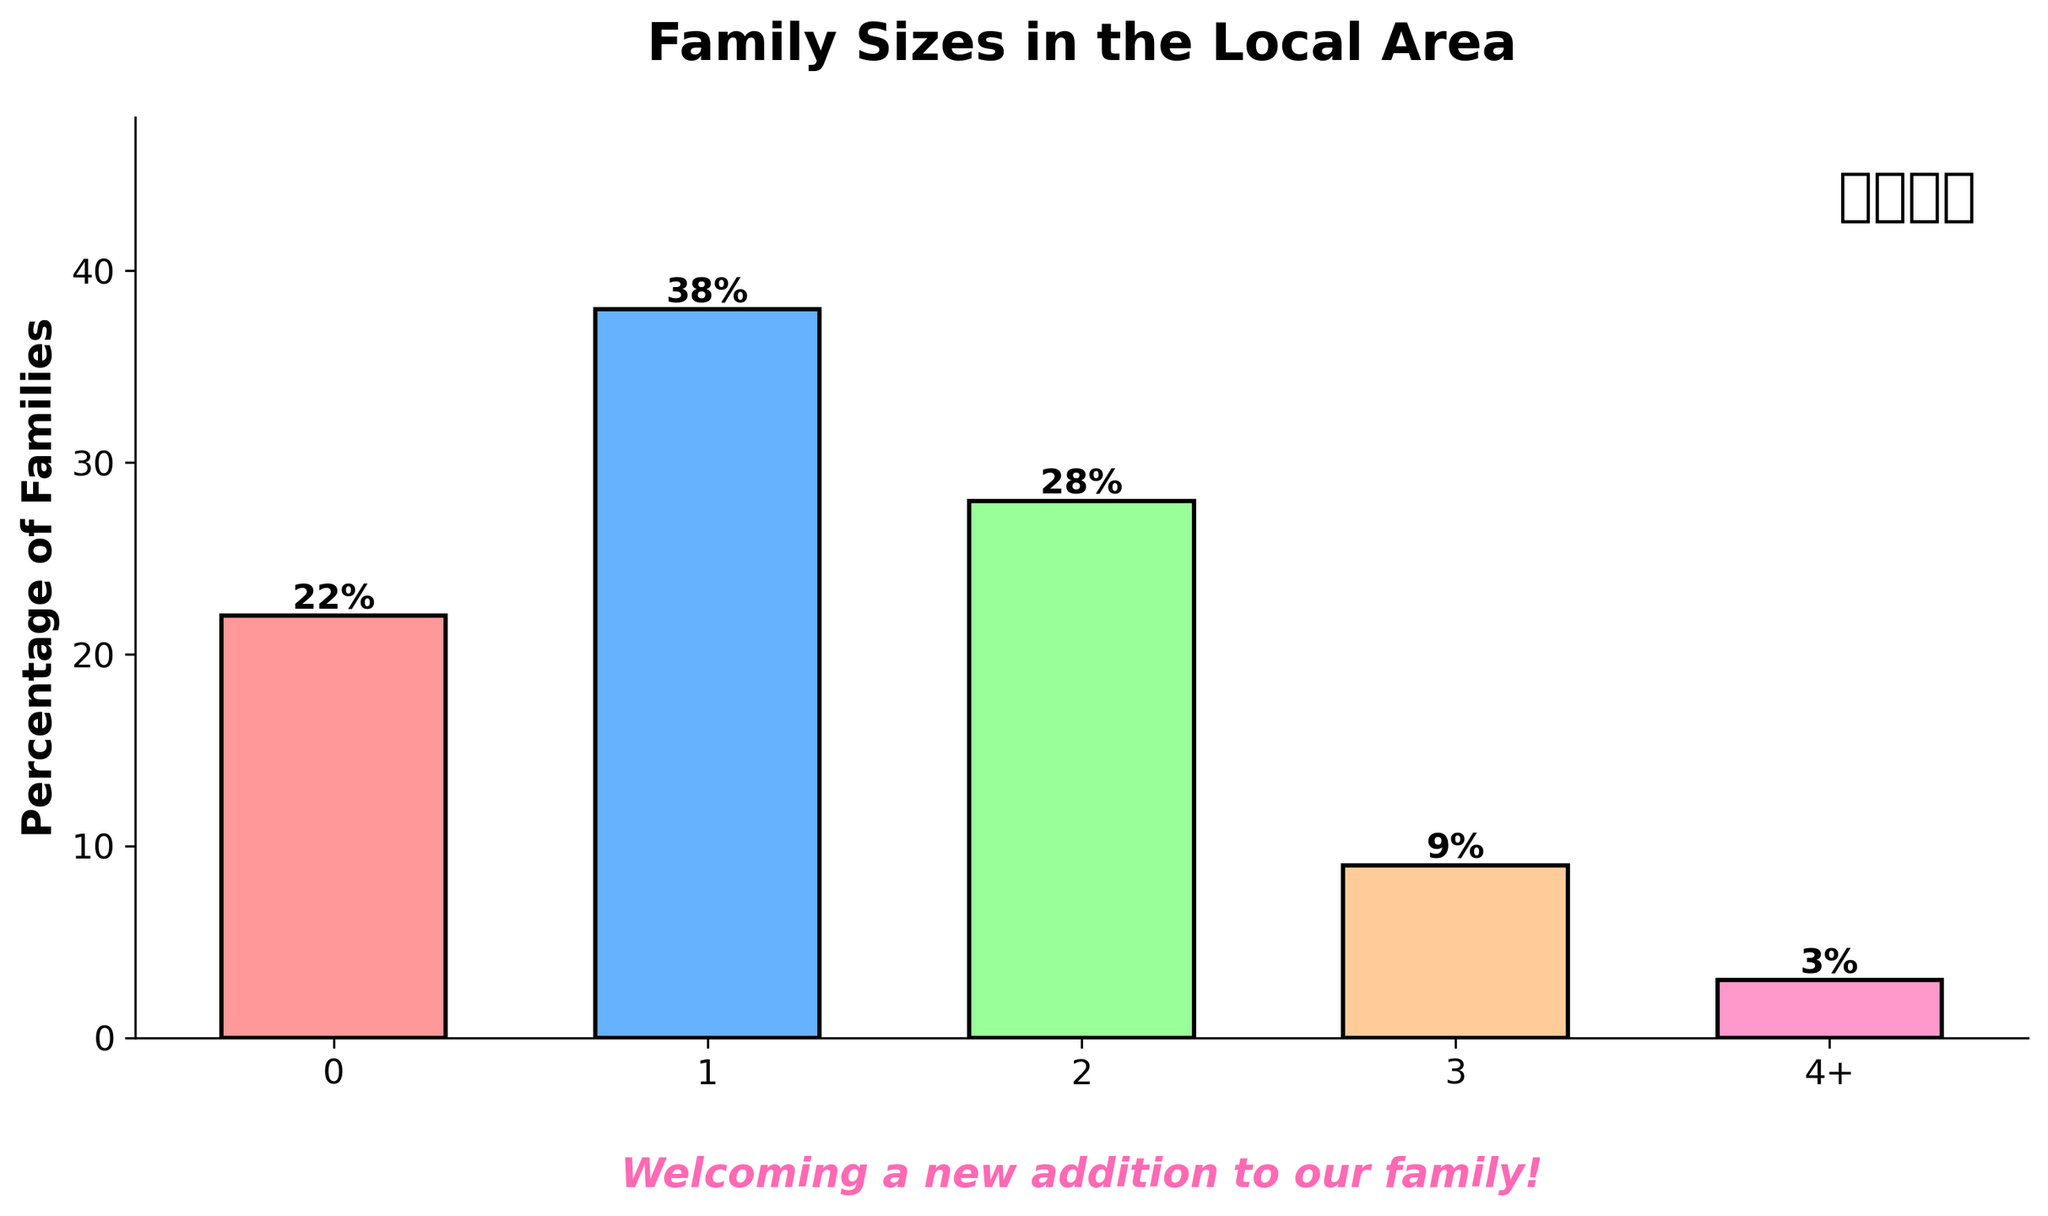What percentage of families have one child? Look at the bar labeled "1" and read the height of the bar. The label on top of this bar says "38%", indicating the percentage of families with one child.
Answer: 38% Which group has the highest percentage of families? By comparing the heights of all the bars, we can see that the bar for families with one child is the tallest. The label on this bar shows "38%", which is the highest percentage among all groups.
Answer: Families with one child How many percentage points higher is the percentage of families with two children compared to families with three children? Look at the heights of the bars for families with two children (28%) and three children (9%). Subtract the percentage for three children from the percentage for two children: 28% - 9% = 19%.
Answer: 19% What is the combined percentage of families with three or more children? Add the percentages for families with three children (9%) and families with four or more children (3%): 9% + 3% = 12%.
Answer: 12% Which color represents families with no children? Look at the color of the bar labeled "0". The color of this bar is red.
Answer: Red How many percentage points higher is the percentage of families with one child compared to families with no children? Look at the heights of the bars for families with one child (38%) and no children (22%). Subtract the percentage for no children from the percentage for one child: 38% - 22% = 16%.
Answer: 16% What is the total percentage of families with one or two children? Add the percentages for families with one child (38%) and two children (28%): 38% + 28% = 66%.
Answer: 66% What percentage of families have three or more children? Sum the percentages for families with three children (9%) and those with four or more children (3%): 9% + 3% = 12%.
Answer: 12% Which group has the lowest percentage of families? By comparing the heights of all the bars, we can see that the bar for families with four or more children is the shortest. The label on top of this bar shows "3%", which is the lowest percentage among all groups.
Answer: Families with four or more children 